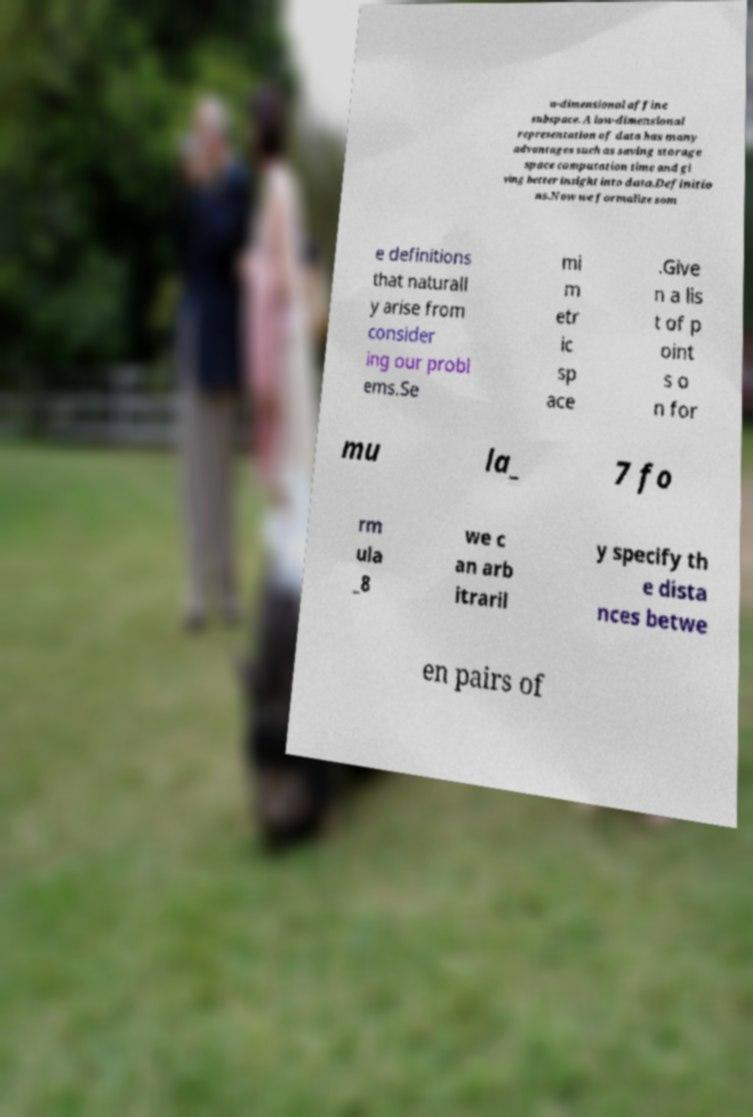There's text embedded in this image that I need extracted. Can you transcribe it verbatim? w-dimensional affine subspace. A low-dimensional representation of data has many advantages such as saving storage space computation time and gi ving better insight into data.Definitio ns.Now we formalize som e definitions that naturall y arise from consider ing our probl ems.Se mi m etr ic sp ace .Give n a lis t of p oint s o n for mu la_ 7 fo rm ula _8 we c an arb itraril y specify th e dista nces betwe en pairs of 